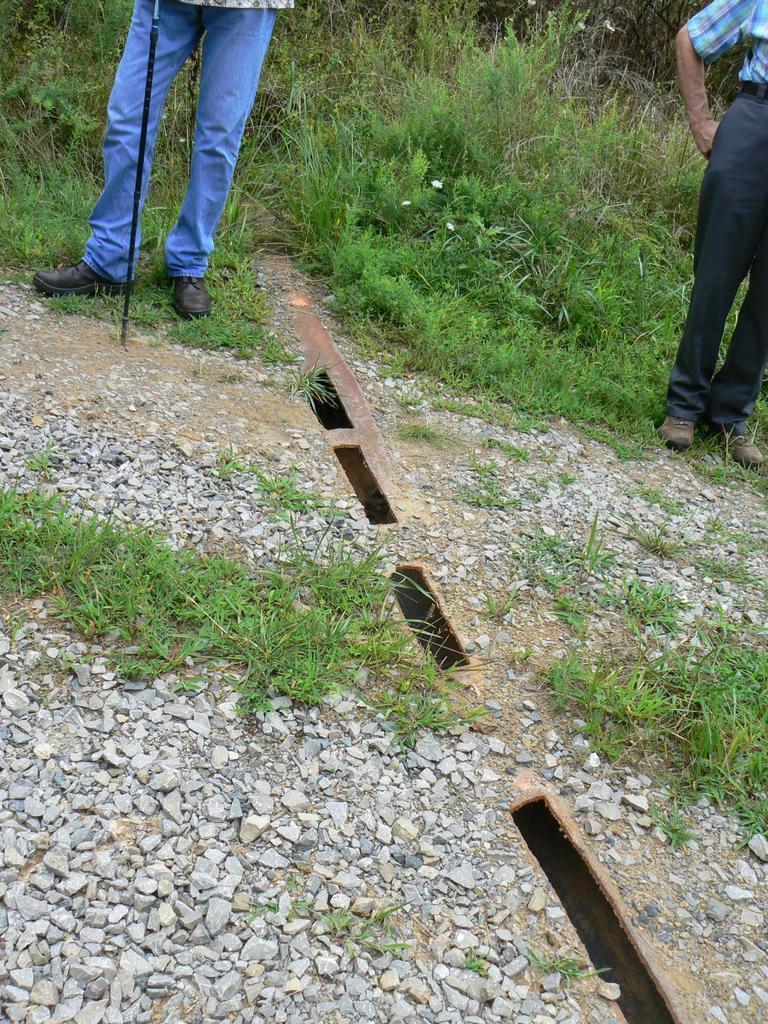Describe this image in one or two sentences. In this picture we can see two people standing on the ground, stones, grass, stick and in the background we can see plants. 